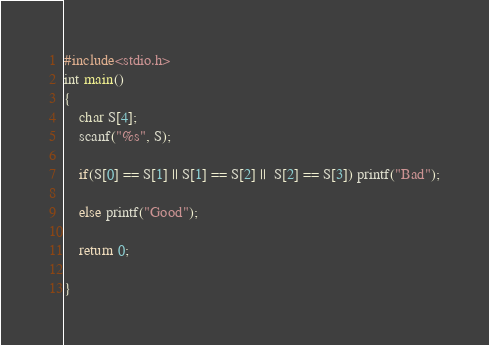<code> <loc_0><loc_0><loc_500><loc_500><_C_>#include<stdio.h>
int main()
{
	char S[4];
	scanf("%s", S);
	
	if(S[0] == S[1] || S[1] == S[2] ||  S[2] == S[3]) printf("Bad");
	
	else printf("Good");
	
	return 0;
	
}</code> 